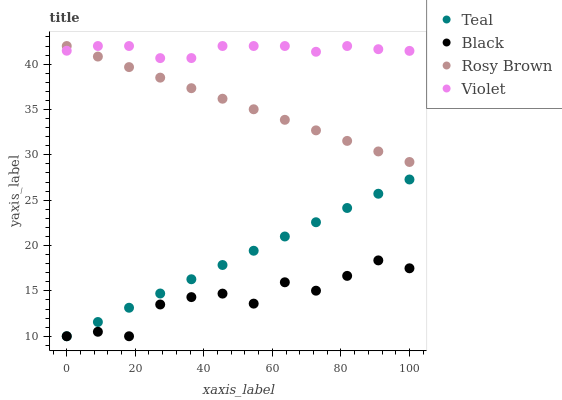Does Black have the minimum area under the curve?
Answer yes or no. Yes. Does Violet have the maximum area under the curve?
Answer yes or no. Yes. Does Teal have the minimum area under the curve?
Answer yes or no. No. Does Teal have the maximum area under the curve?
Answer yes or no. No. Is Teal the smoothest?
Answer yes or no. Yes. Is Black the roughest?
Answer yes or no. Yes. Is Black the smoothest?
Answer yes or no. No. Is Teal the roughest?
Answer yes or no. No. Does Black have the lowest value?
Answer yes or no. Yes. Does Violet have the lowest value?
Answer yes or no. No. Does Violet have the highest value?
Answer yes or no. Yes. Does Teal have the highest value?
Answer yes or no. No. Is Black less than Violet?
Answer yes or no. Yes. Is Rosy Brown greater than Black?
Answer yes or no. Yes. Does Violet intersect Rosy Brown?
Answer yes or no. Yes. Is Violet less than Rosy Brown?
Answer yes or no. No. Is Violet greater than Rosy Brown?
Answer yes or no. No. Does Black intersect Violet?
Answer yes or no. No. 